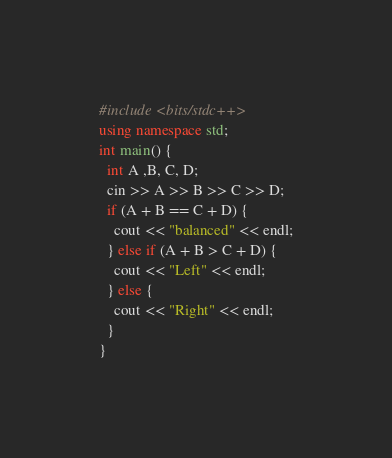Convert code to text. <code><loc_0><loc_0><loc_500><loc_500><_C++_>#include <bits/stdc++>
using namespace std;
int main() {
  int A ,B, C, D;
  cin >> A >> B >> C >> D;
  if (A + B == C + D) {
    cout << "balanced" << endl;
  } else if (A + B > C + D) {
    cout << "Left" << endl;
  } else {
    cout << "Right" << endl;
  }
}</code> 